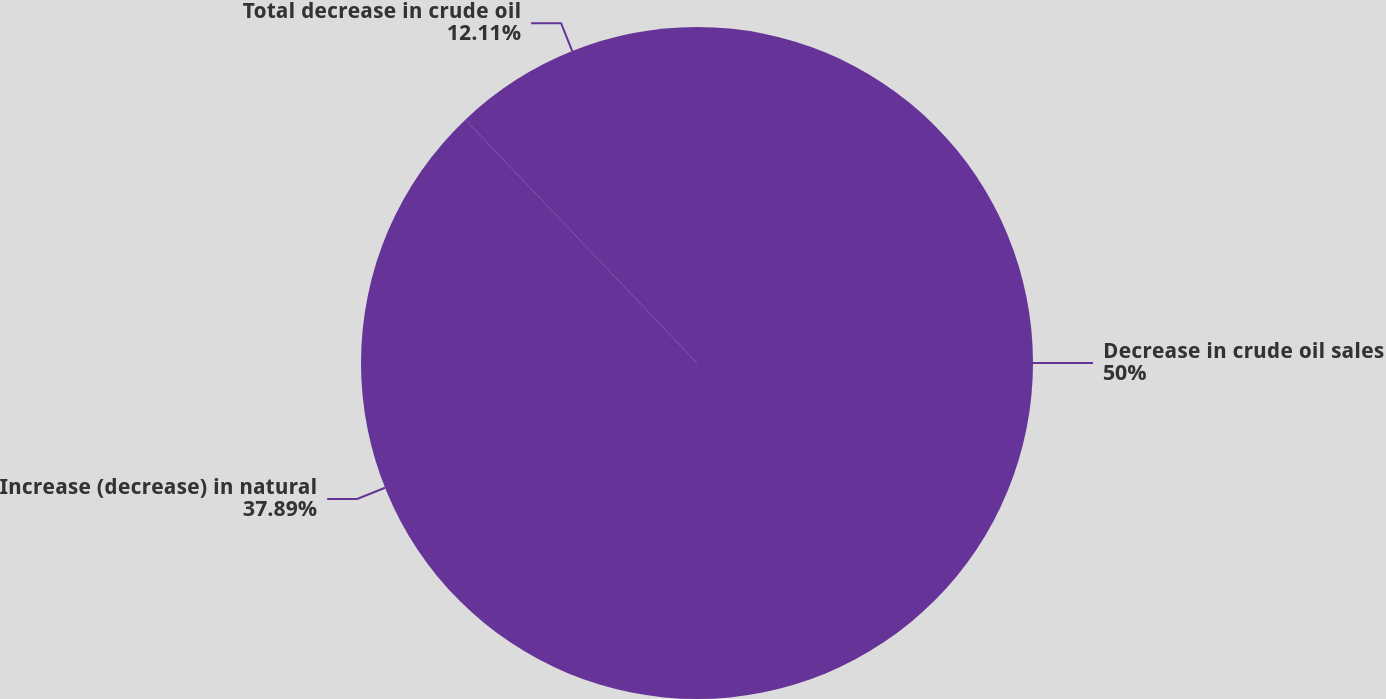<chart> <loc_0><loc_0><loc_500><loc_500><pie_chart><fcel>Decrease in crude oil sales<fcel>Increase (decrease) in natural<fcel>Total decrease in crude oil<nl><fcel>50.0%<fcel>37.89%<fcel>12.11%<nl></chart> 